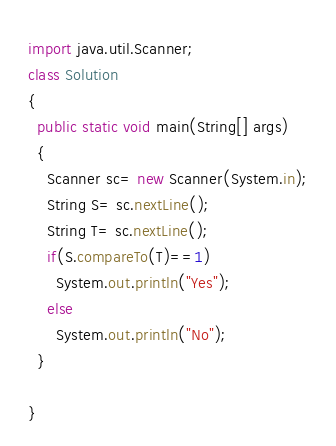Convert code to text. <code><loc_0><loc_0><loc_500><loc_500><_Java_>import java.util.Scanner;
class Solution
{
  public static void main(String[] args)
  {
  	Scanner sc= new Scanner(System.in);
    String S= sc.nextLine();
    String T= sc.nextLine();
    if(S.compareTo(T)==1)
      System.out.println("Yes");
    else
      System.out.println("No");
  }
  
}</code> 